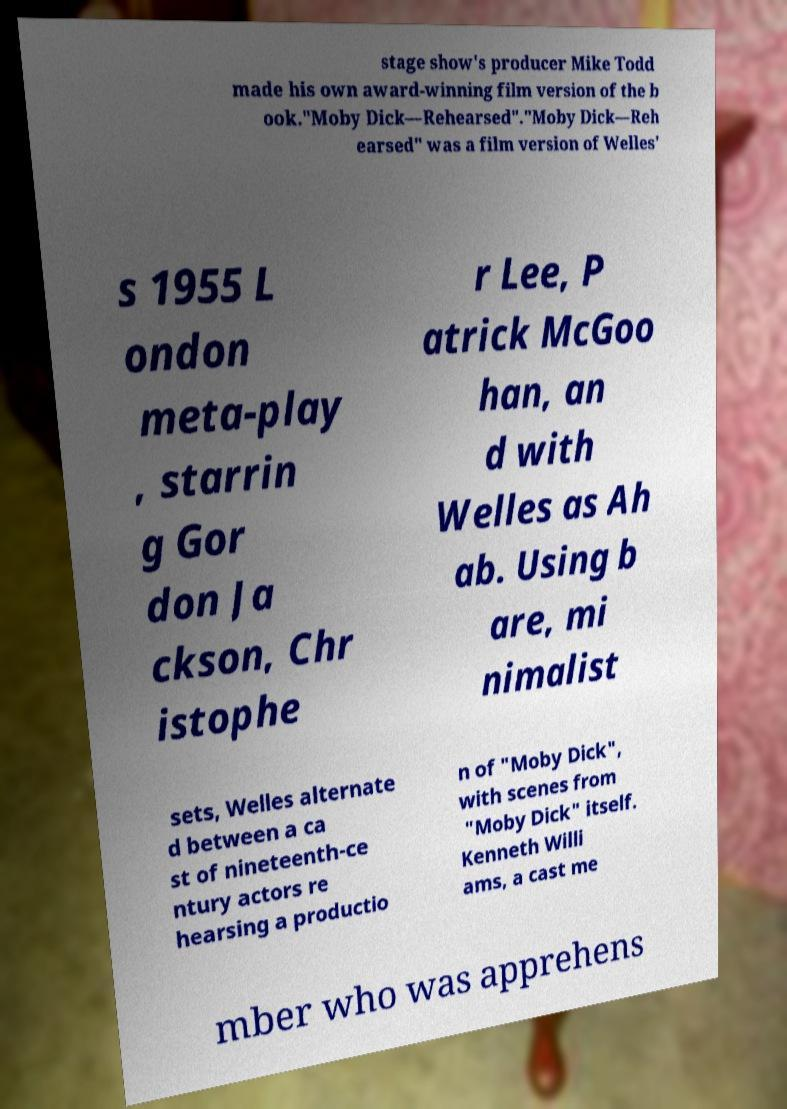I need the written content from this picture converted into text. Can you do that? stage show's producer Mike Todd made his own award-winning film version of the b ook."Moby Dick—Rehearsed"."Moby Dick—Reh earsed" was a film version of Welles' s 1955 L ondon meta-play , starrin g Gor don Ja ckson, Chr istophe r Lee, P atrick McGoo han, an d with Welles as Ah ab. Using b are, mi nimalist sets, Welles alternate d between a ca st of nineteenth-ce ntury actors re hearsing a productio n of "Moby Dick", with scenes from "Moby Dick" itself. Kenneth Willi ams, a cast me mber who was apprehens 